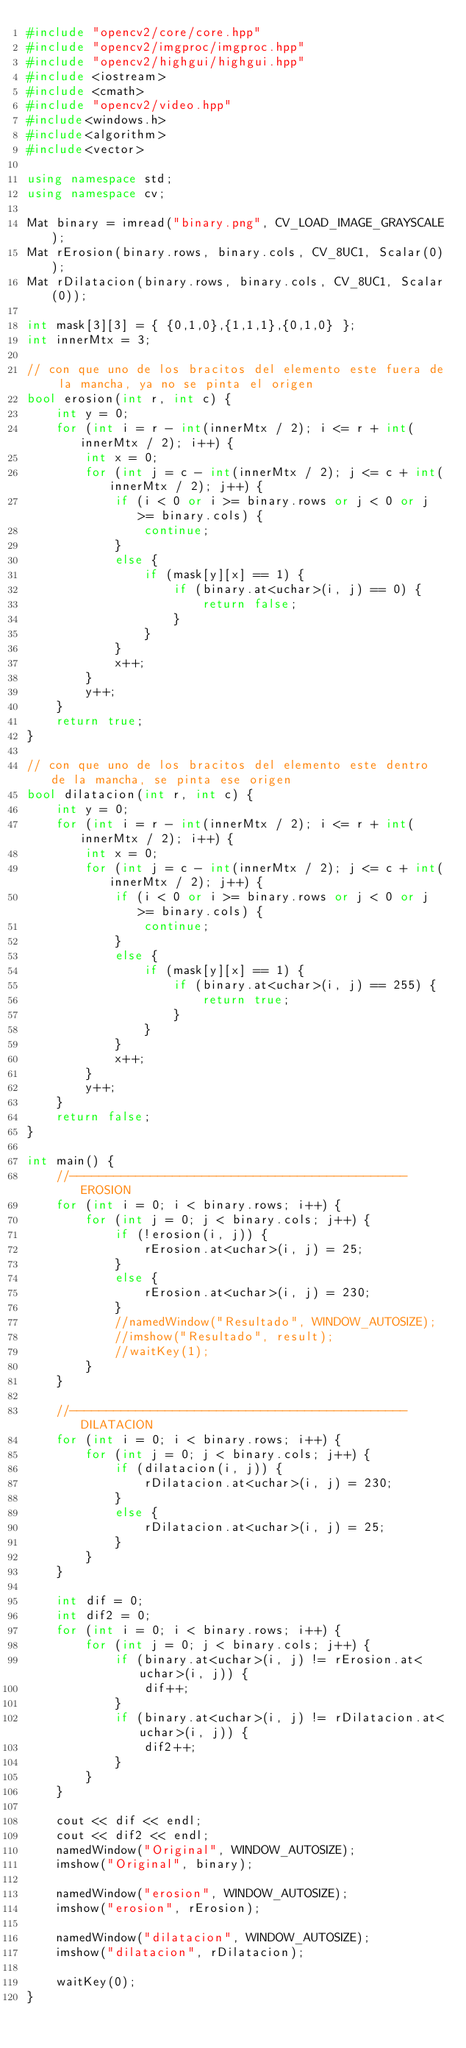Convert code to text. <code><loc_0><loc_0><loc_500><loc_500><_C++_>#include "opencv2/core/core.hpp"
#include "opencv2/imgproc/imgproc.hpp"
#include "opencv2/highgui/highgui.hpp"
#include <iostream>
#include <cmath>
#include "opencv2/video.hpp"
#include<windows.h>
#include<algorithm>
#include<vector>

using namespace std;
using namespace cv;

Mat binary = imread("binary.png", CV_LOAD_IMAGE_GRAYSCALE);
Mat rErosion(binary.rows, binary.cols, CV_8UC1, Scalar(0));
Mat rDilatacion(binary.rows, binary.cols, CV_8UC1, Scalar(0));

int mask[3][3] = { {0,1,0},{1,1,1},{0,1,0} };
int innerMtx = 3;

// con que uno de los bracitos del elemento este fuera de la mancha, ya no se pinta el origen
bool erosion(int r, int c) {
	int y = 0;
	for (int i = r - int(innerMtx / 2); i <= r + int(innerMtx / 2); i++) {
		int x = 0;
		for (int j = c - int(innerMtx / 2); j <= c + int(innerMtx / 2); j++) {
			if (i < 0 or i >= binary.rows or j < 0 or j >= binary.cols) {
				continue;
			}
			else {
				if (mask[y][x] == 1) {
					if (binary.at<uchar>(i, j) == 0) {
						return false;
					}
				}
			}
			x++;
		}
		y++;
	}
	return true;
}

// con que uno de los bracitos del elemento este dentro de la mancha, se pinta ese origen
bool dilatacion(int r, int c) {
	int y = 0;
	for (int i = r - int(innerMtx / 2); i <= r + int(innerMtx / 2); i++) {
		int x = 0;
		for (int j = c - int(innerMtx / 2); j <= c + int(innerMtx / 2); j++) {
			if (i < 0 or i >= binary.rows or j < 0 or j >= binary.cols) {
				continue;
			}
			else {
				if (mask[y][x] == 1) {
					if (binary.at<uchar>(i, j) == 255) {
						return true;
					}
				}
			}
			x++;
		}
		y++;
	}
	return false;
}

int main() {
	//---------------------------------------------- EROSION
	for (int i = 0; i < binary.rows; i++) {
		for (int j = 0; j < binary.cols; j++) {
			if (!erosion(i, j)) {
				rErosion.at<uchar>(i, j) = 25;
			}
			else {
				rErosion.at<uchar>(i, j) = 230;
			}
			//namedWindow("Resultado", WINDOW_AUTOSIZE);
			//imshow("Resultado", result);
			//waitKey(1);
		}
	}

	//---------------------------------------------- DILATACION
	for (int i = 0; i < binary.rows; i++) {
		for (int j = 0; j < binary.cols; j++) {
			if (dilatacion(i, j)) {
				rDilatacion.at<uchar>(i, j) = 230;
			}
			else {
				rDilatacion.at<uchar>(i, j) = 25;
			}
		}
	}

	int dif = 0;
	int dif2 = 0;
	for (int i = 0; i < binary.rows; i++) {
		for (int j = 0; j < binary.cols; j++) {
			if (binary.at<uchar>(i, j) != rErosion.at<uchar>(i, j)) {
				dif++;
			}
			if (binary.at<uchar>(i, j) != rDilatacion.at<uchar>(i, j)) {
				dif2++;
			}
		}
	}

	cout << dif << endl;
	cout << dif2 << endl;
	namedWindow("Original", WINDOW_AUTOSIZE);
	imshow("Original", binary);

	namedWindow("erosion", WINDOW_AUTOSIZE);
	imshow("erosion", rErosion);

	namedWindow("dilatacion", WINDOW_AUTOSIZE);
	imshow("dilatacion", rDilatacion);

	waitKey(0);
}</code> 